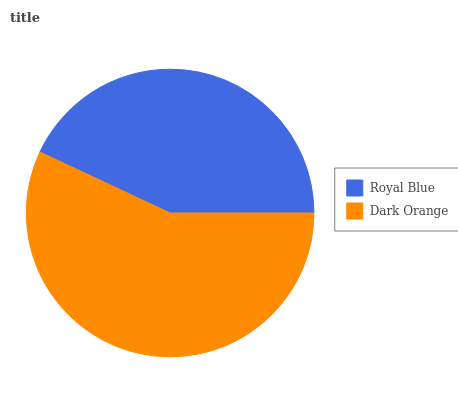Is Royal Blue the minimum?
Answer yes or no. Yes. Is Dark Orange the maximum?
Answer yes or no. Yes. Is Dark Orange the minimum?
Answer yes or no. No. Is Dark Orange greater than Royal Blue?
Answer yes or no. Yes. Is Royal Blue less than Dark Orange?
Answer yes or no. Yes. Is Royal Blue greater than Dark Orange?
Answer yes or no. No. Is Dark Orange less than Royal Blue?
Answer yes or no. No. Is Dark Orange the high median?
Answer yes or no. Yes. Is Royal Blue the low median?
Answer yes or no. Yes. Is Royal Blue the high median?
Answer yes or no. No. Is Dark Orange the low median?
Answer yes or no. No. 